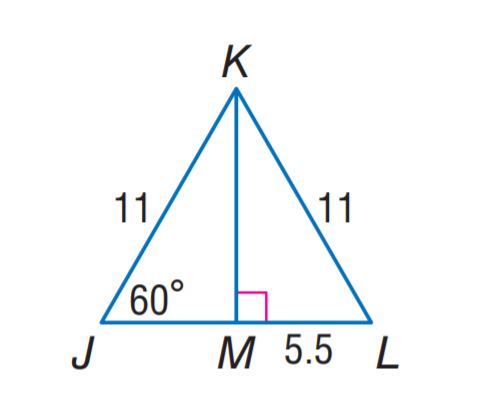Answer the mathemtical geometry problem and directly provide the correct option letter.
Question: Find J M.
Choices: A: 4.5 B: 5.5 C: 6 D: 11 B 